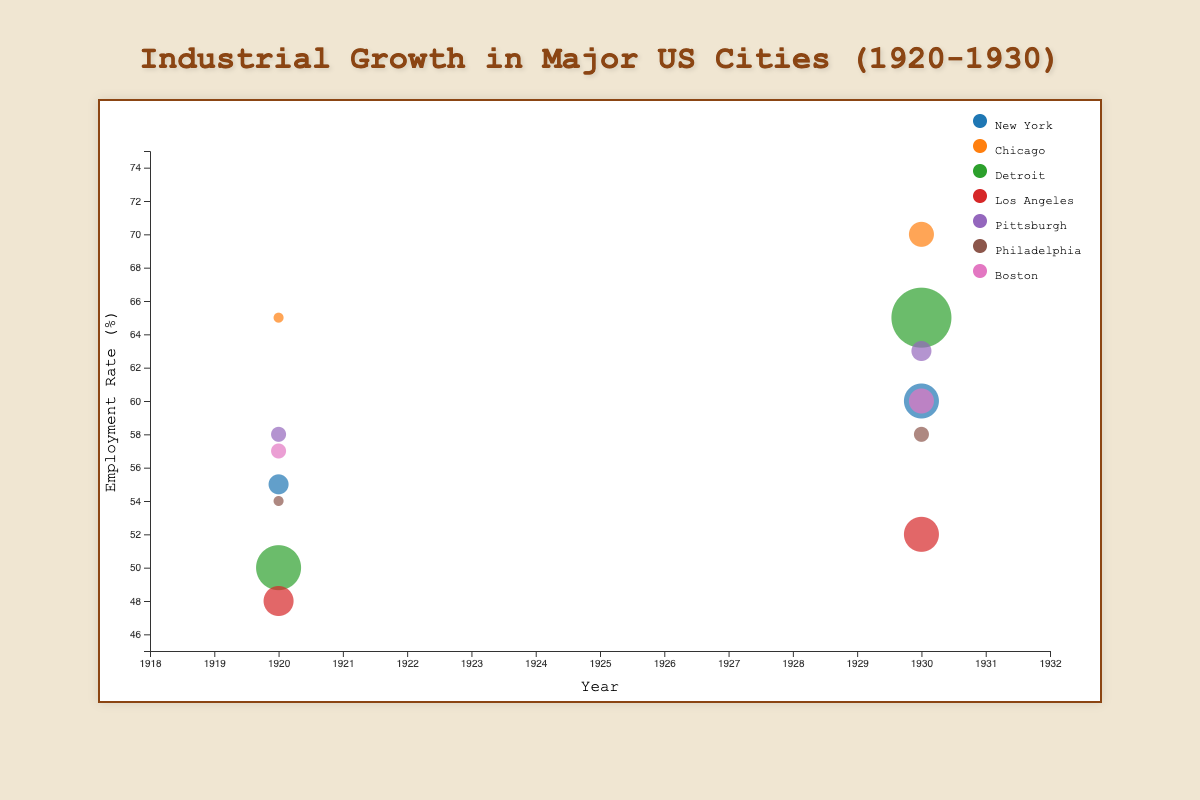What's the title of the figure? The title is displayed prominently at the top of the chart and reads "Industrial Growth in Major US Cities (1920-1930)."
Answer: Industrial Growth in Major US Cities (1920-1930) What are the X and Y axes' labels? The X-axis label is found below the horizontal axis and reads "Year," while the Y-axis label is rotated vertically along the Y-axis and reads "Employment Rate (%)".
Answer: X: Year, Y: Employment Rate (%) What city had the highest employment rate in 1930? From the bubbles at the 1930 tick mark, Chicago has the highest bubble on the Y-axis, indicating the highest employment rate.
Answer: Chicago Which city shows the most significant change in employment rate from 1920 to 1930? By observing the Y-axis values for each city in both years, Detroit shows the largest difference, from 50% in 1920 to 65% in 1930, an increase of 15%.
Answer: Detroit What industrial sector was prominent in Pittsburgh in 1930? Hovering over the bubble for Pittsburgh in 1930 reveals the tooltip with details, indicating the industrial sector was Steel.
Answer: Steel Compare the employment rate in New York and Los Angeles in 1920. Which city had a higher rate? The bubble for New York in 1920 is higher on the Y-axis compared to the bubble for Los Angeles, indicating New York had a higher employment rate.
Answer: New York Which city had the fastest growth rate in 1920? By comparing the sizes of the bubbles for 1920, Detroit's bubble is the largest, indicating the highest growth rate of 12%.
Answer: Detroit What is the most common industrial sector in the data? Examining the tooltips or color code reveals that Steel appears most frequently (Chicago, Pittsburgh in both 1920 and 1930).
Answer: Steel Which city transitioned to a new industrial sector between 1920 and 1930? Observing the industrial sectors for each city, New York moved from Textiles (1920) to Finance (1930), and Los Angeles moved from Entertainment (1920) to Technology (1930). Either one can be the answer.
Answer: New York or Los Angeles 